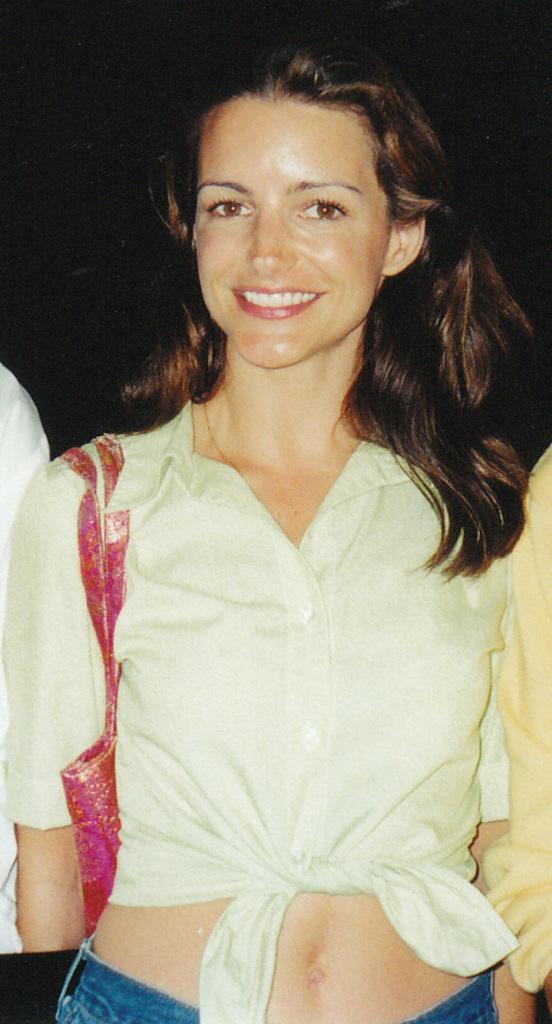Could you give a brief overview of what you see in this image? In this picture there is a woman in white dress, she's wearing a bag and she is smiling. On the left we can see a person's hand. The background is dark. 